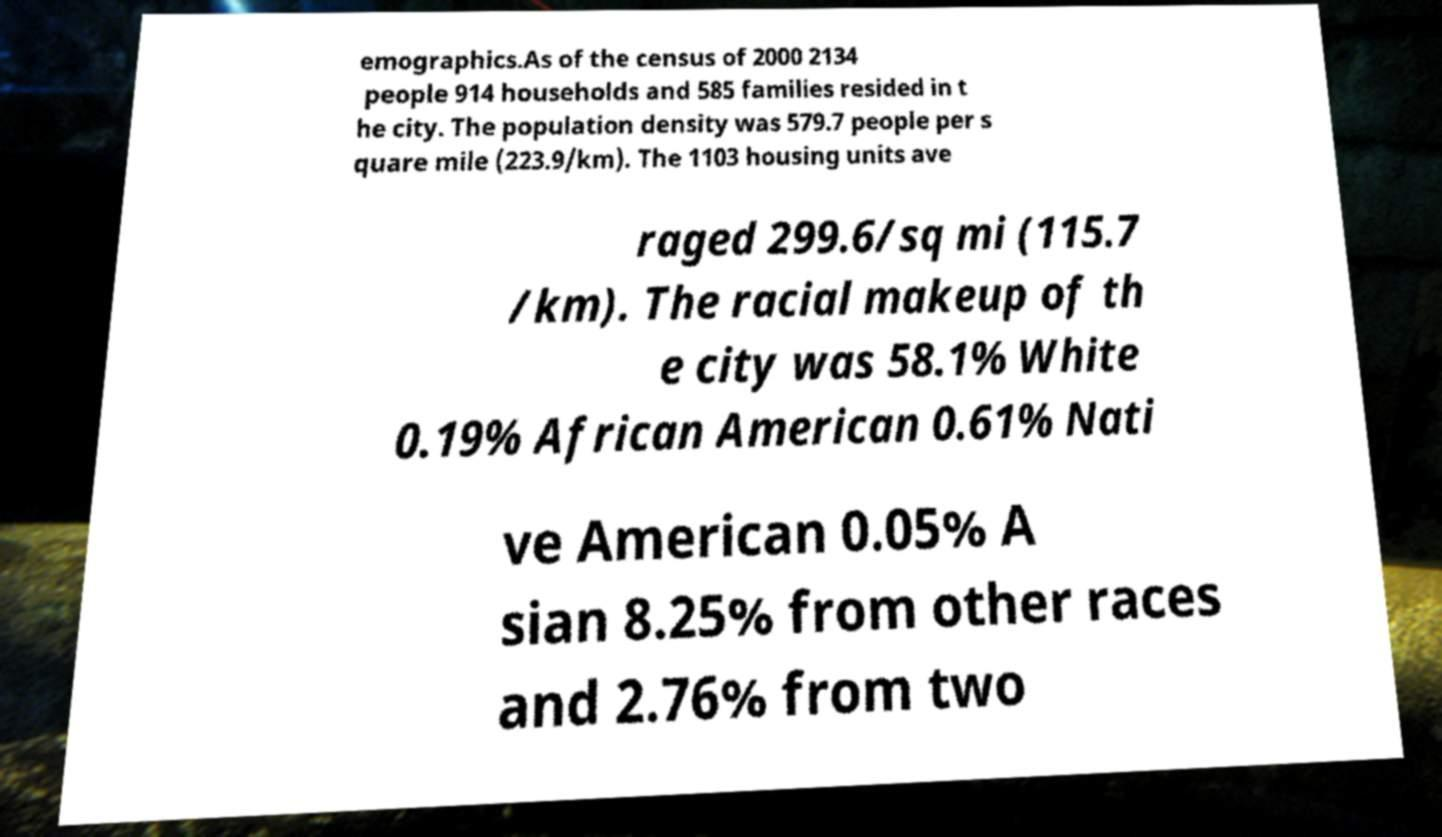Please identify and transcribe the text found in this image. emographics.As of the census of 2000 2134 people 914 households and 585 families resided in t he city. The population density was 579.7 people per s quare mile (223.9/km). The 1103 housing units ave raged 299.6/sq mi (115.7 /km). The racial makeup of th e city was 58.1% White 0.19% African American 0.61% Nati ve American 0.05% A sian 8.25% from other races and 2.76% from two 